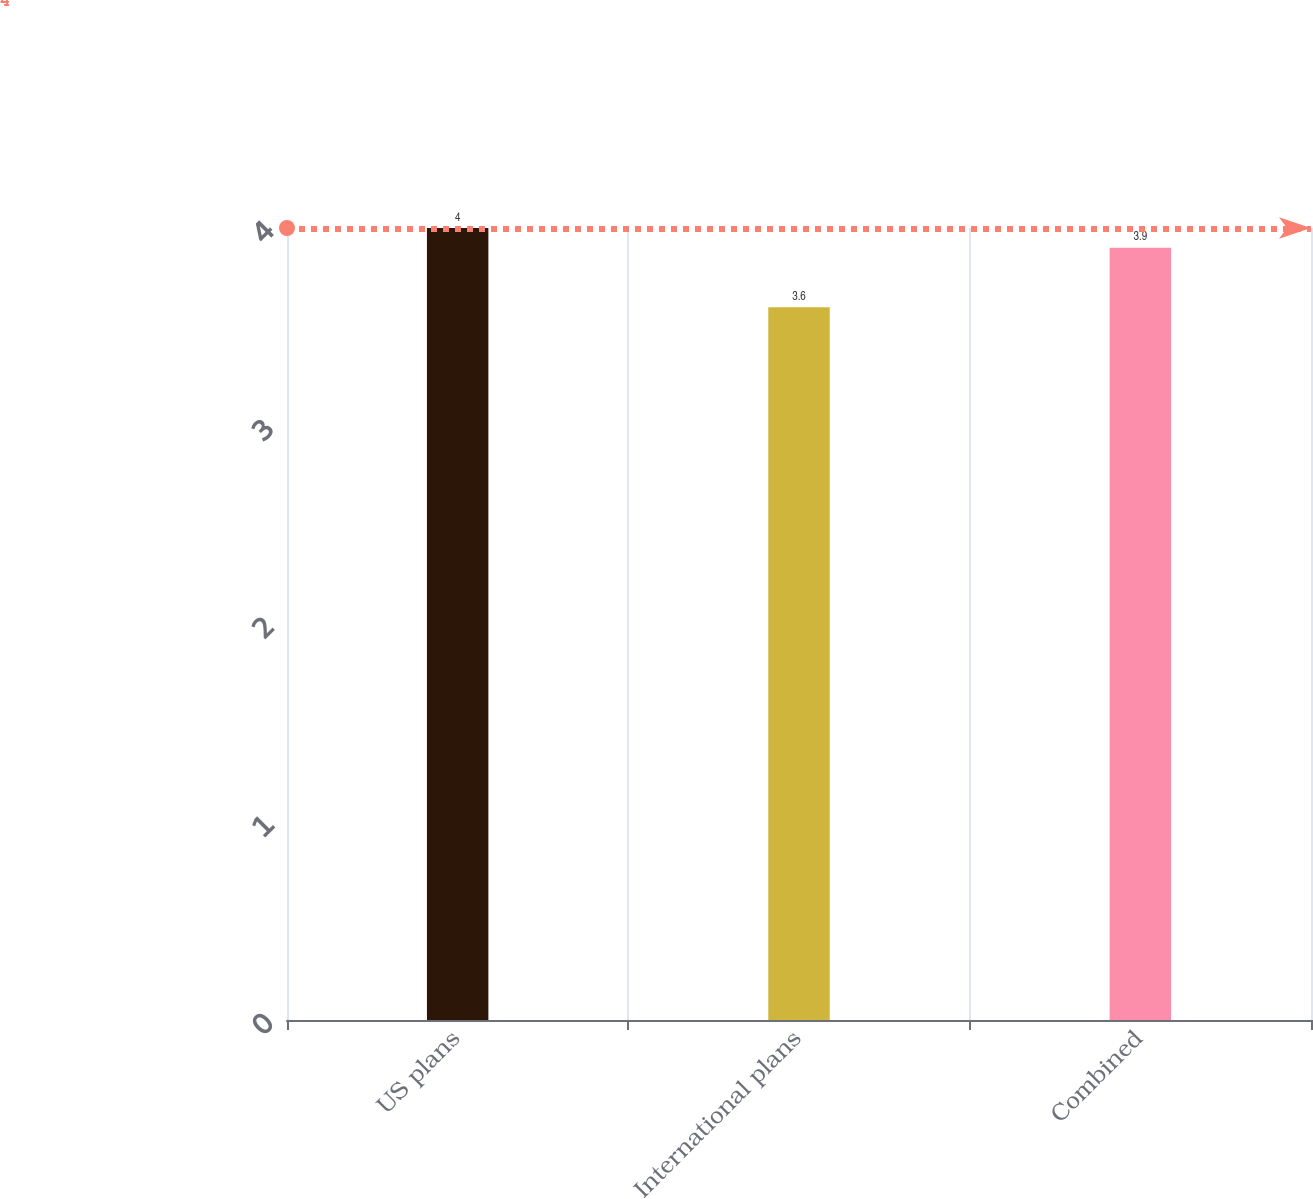Convert chart to OTSL. <chart><loc_0><loc_0><loc_500><loc_500><bar_chart><fcel>US plans<fcel>International plans<fcel>Combined<nl><fcel>4<fcel>3.6<fcel>3.9<nl></chart> 